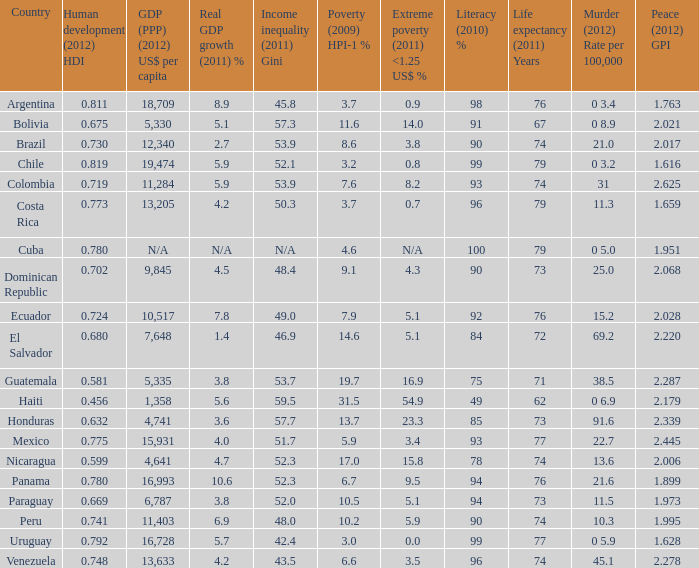What homicide (2012) rate per 100,000 also has a 0 3.2. 